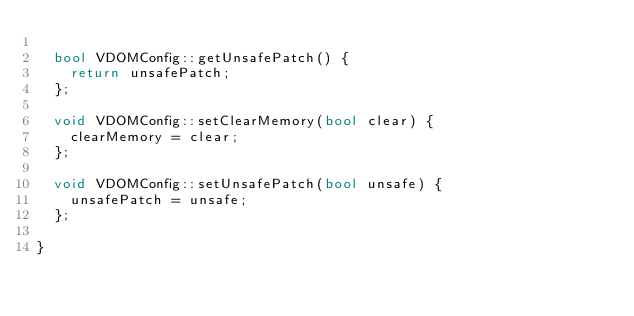Convert code to text. <code><loc_0><loc_0><loc_500><loc_500><_C++_>
	bool VDOMConfig::getUnsafePatch() {
		return unsafePatch;
	};

	void VDOMConfig::setClearMemory(bool clear) {
		clearMemory = clear;
	};

	void VDOMConfig::setUnsafePatch(bool unsafe) {
		unsafePatch = unsafe;
	};

}
</code> 